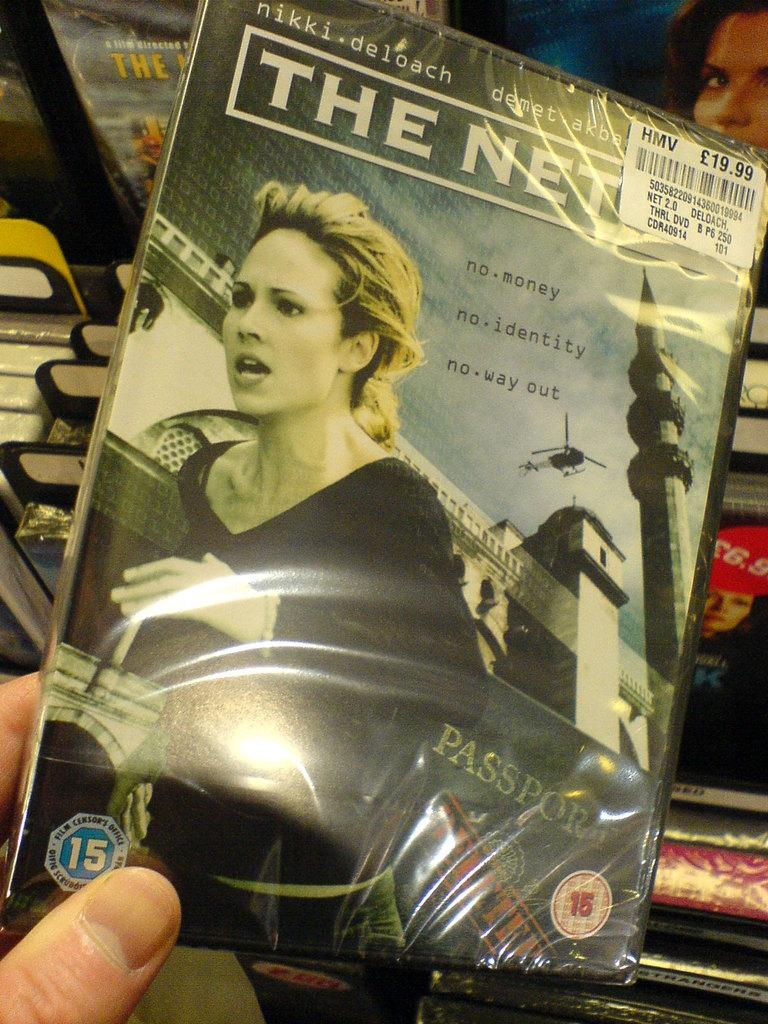Provide a one-sentence caption for the provided image. A brand new, sealed DVD of a film called The Net. 